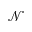<formula> <loc_0><loc_0><loc_500><loc_500>\mathcal { N }</formula> 